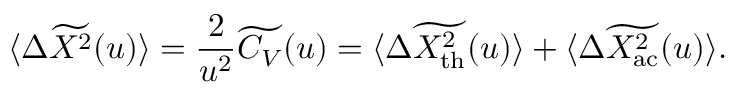<formula> <loc_0><loc_0><loc_500><loc_500>\langle \Delta \widetilde { X ^ { 2 } } ( u ) \rangle = \frac { 2 } { u ^ { 2 } } \widetilde { C _ { V } } ( u ) = \langle \Delta \widetilde { X _ { t h } ^ { 2 } } ( u ) \rangle + \langle \Delta \widetilde { X _ { a c } ^ { 2 } } ( u ) \rangle .</formula> 